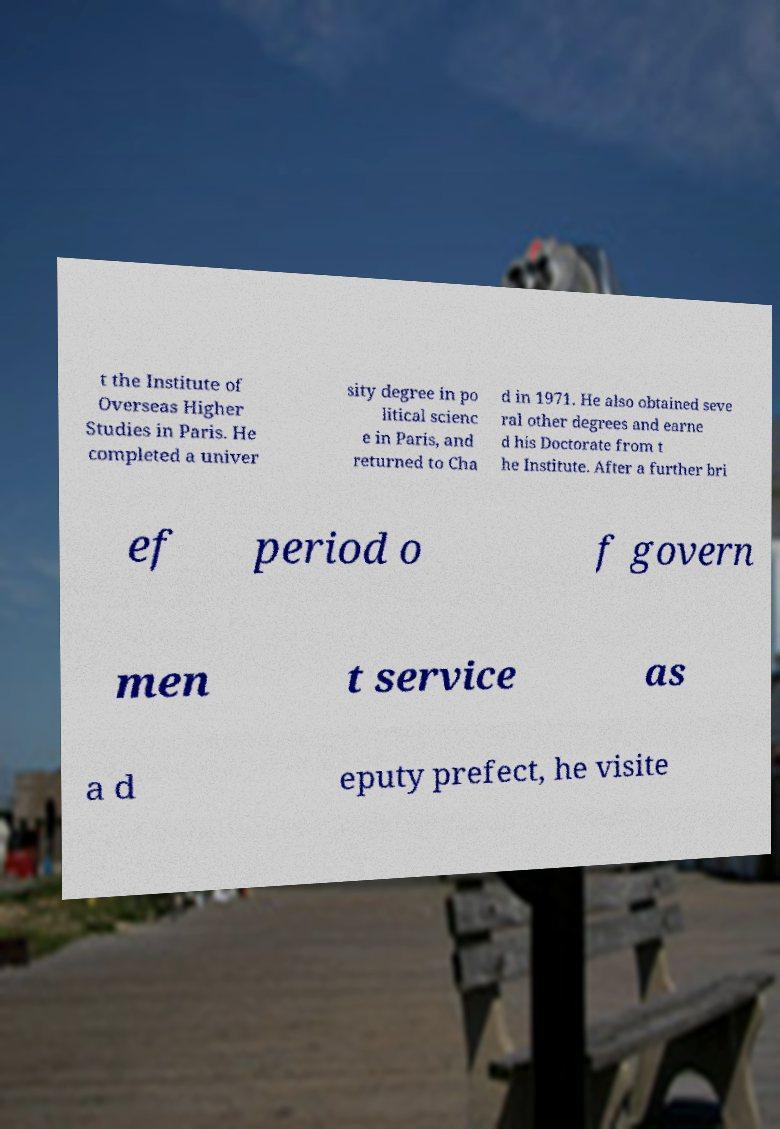What messages or text are displayed in this image? I need them in a readable, typed format. t the Institute of Overseas Higher Studies in Paris. He completed a univer sity degree in po litical scienc e in Paris, and returned to Cha d in 1971. He also obtained seve ral other degrees and earne d his Doctorate from t he Institute. After a further bri ef period o f govern men t service as a d eputy prefect, he visite 